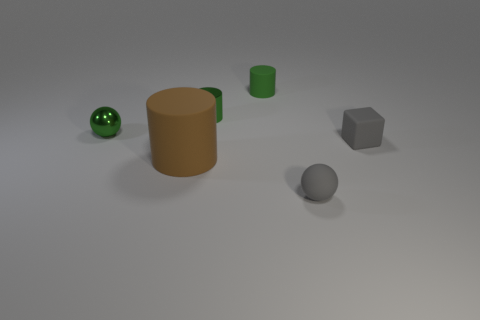Are there any other things that have the same shape as the big brown object?
Provide a succinct answer. Yes. Are there any large gray rubber balls?
Your answer should be very brief. No. There is a rubber cylinder that is in front of the matte cube; does it have the same size as the green shiny object on the right side of the green metallic sphere?
Provide a short and direct response. No. What is the material of the object that is both in front of the tiny shiny sphere and behind the big rubber thing?
Your answer should be compact. Rubber. There is a matte sphere; what number of rubber objects are right of it?
Make the answer very short. 1. Is there anything else that has the same size as the brown cylinder?
Ensure brevity in your answer.  No. The object that is the same material as the tiny green ball is what color?
Offer a very short reply. Green. What number of matte things are both in front of the tiny rubber cylinder and to the left of the small gray matte ball?
Make the answer very short. 1. How many rubber objects are either green objects or yellow cylinders?
Offer a terse response. 1. There is a brown matte cylinder that is left of the gray thing to the left of the small rubber block; what is its size?
Keep it short and to the point. Large. 